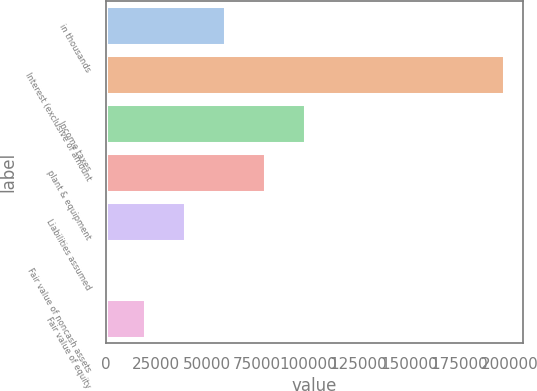<chart> <loc_0><loc_0><loc_500><loc_500><bar_chart><fcel>in thousands<fcel>Interest (exclusive of amount<fcel>Income taxes<fcel>plant & equipment<fcel>Liabilities assumed<fcel>Fair value of noncash assets<fcel>Fair value of equity<nl><fcel>59038.4<fcel>196794<fcel>98397.2<fcel>78717.8<fcel>39359.1<fcel>0.32<fcel>19679.7<nl></chart> 